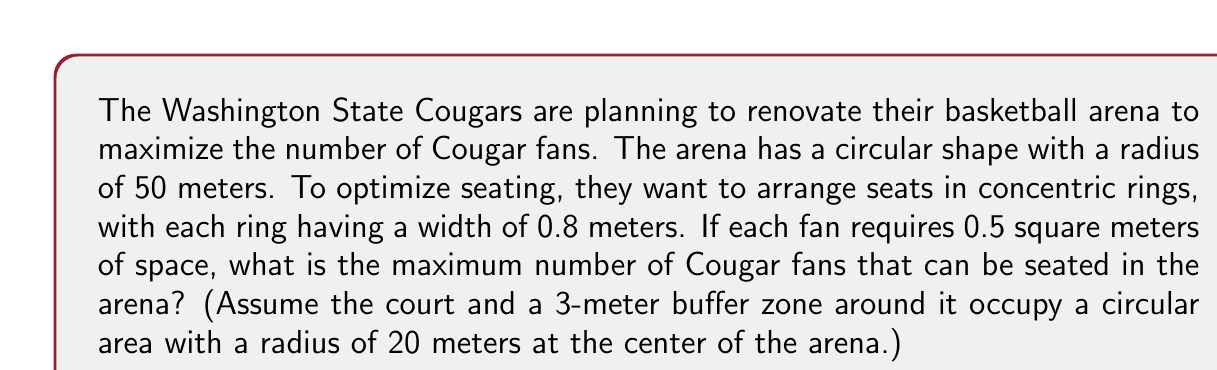Show me your answer to this math problem. Let's approach this problem step by step:

1) First, we need to calculate the area available for seating. The total area of the arena minus the area of the court and buffer zone:

   $$A_{total} = \pi R^2 - \pi r^2 = \pi(50^2 - 20^2) = 6300\pi \text{ m}^2$$

2) Now, we need to consider the concentric rings. The width of each ring is 0.8 meters. Let's calculate how many rings we can fit:

   $$\text{Number of rings} = \frac{50 - 20}{0.8} = 37.5$$

   We round down to 37 full rings.

3) To calculate the area of each ring, we can use the formula:

   $$A_{ring} = \pi[(r + w)^2 - r^2]$$

   where $r$ is the inner radius of the ring and $w$ is the width.

4) We need to sum the areas of all rings:

   $$A_{total} = \pi\sum_{i=0}^{36}[(20 + 0.8i + 0.8)^2 - (20 + 0.8i)^2]$$

5) Simplifying:

   $$A_{total} = 1.6\pi\sum_{i=0}^{36}(40 + 1.6i + 0.8)$$

6) This sum can be calculated as:

   $$A_{total} = 1.6\pi[37(40 + 0.8) + 1.6\frac{36 \cdot 37}{2}] = 6241.6\pi \text{ m}^2$$

7) Each fan requires 0.5 square meters, so the maximum number of fans is:

   $$\text{Number of fans} = \frac{6241.6\pi}{0.5} = 39173.45$$

Rounding down, we get 39,173 fans.
Answer: The maximum number of Cougar fans that can be seated in the optimized arena is 39,173. 